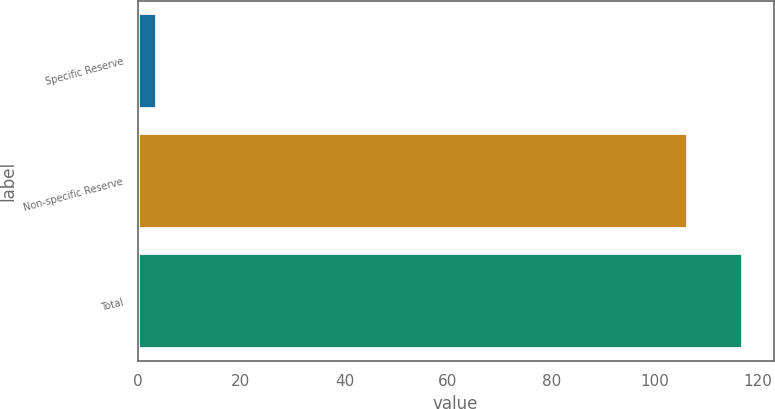Convert chart. <chart><loc_0><loc_0><loc_500><loc_500><bar_chart><fcel>Specific Reserve<fcel>Non-specific Reserve<fcel>Total<nl><fcel>3.8<fcel>106.5<fcel>117.15<nl></chart> 